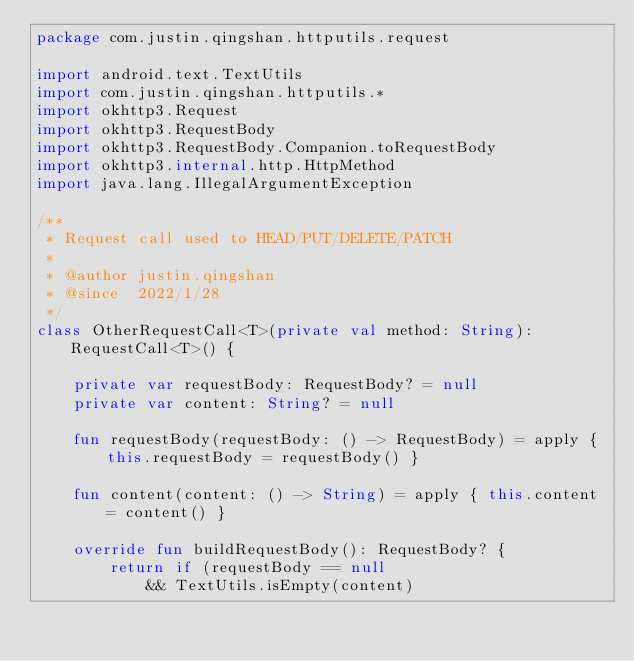<code> <loc_0><loc_0><loc_500><loc_500><_Kotlin_>package com.justin.qingshan.httputils.request

import android.text.TextUtils
import com.justin.qingshan.httputils.*
import okhttp3.Request
import okhttp3.RequestBody
import okhttp3.RequestBody.Companion.toRequestBody
import okhttp3.internal.http.HttpMethod
import java.lang.IllegalArgumentException

/**
 * Request call used to HEAD/PUT/DELETE/PATCH
 *
 * @author justin.qingshan
 * @since  2022/1/28
 */
class OtherRequestCall<T>(private val method: String): RequestCall<T>() {

    private var requestBody: RequestBody? = null
    private var content: String? = null

    fun requestBody(requestBody: () -> RequestBody) = apply { this.requestBody = requestBody() }

    fun content(content: () -> String) = apply { this.content = content() }

    override fun buildRequestBody(): RequestBody? {
        return if (requestBody == null
            && TextUtils.isEmpty(content)</code> 